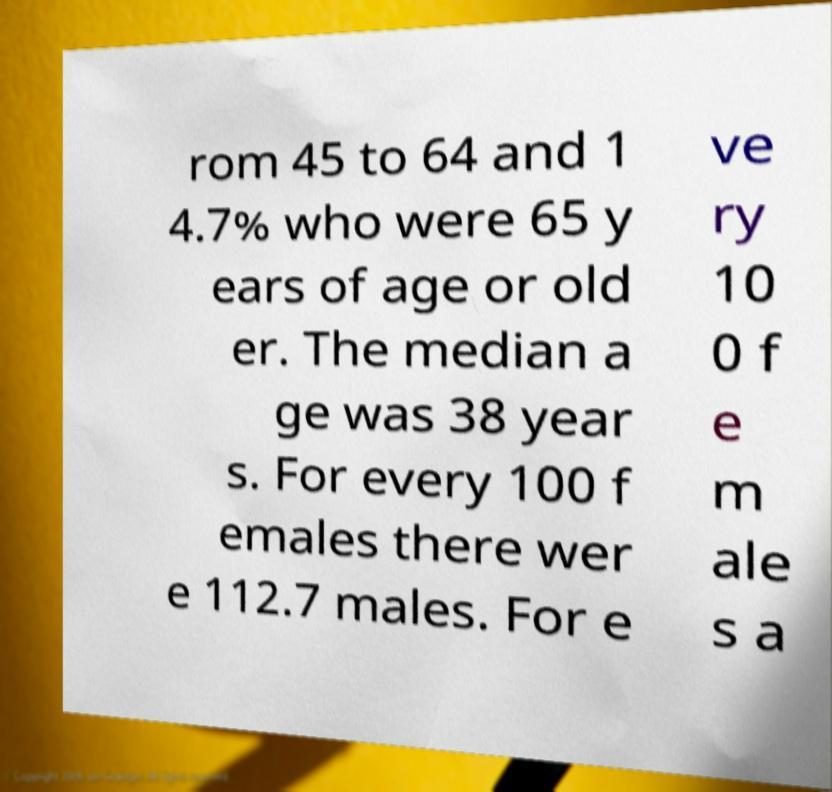Please identify and transcribe the text found in this image. rom 45 to 64 and 1 4.7% who were 65 y ears of age or old er. The median a ge was 38 year s. For every 100 f emales there wer e 112.7 males. For e ve ry 10 0 f e m ale s a 